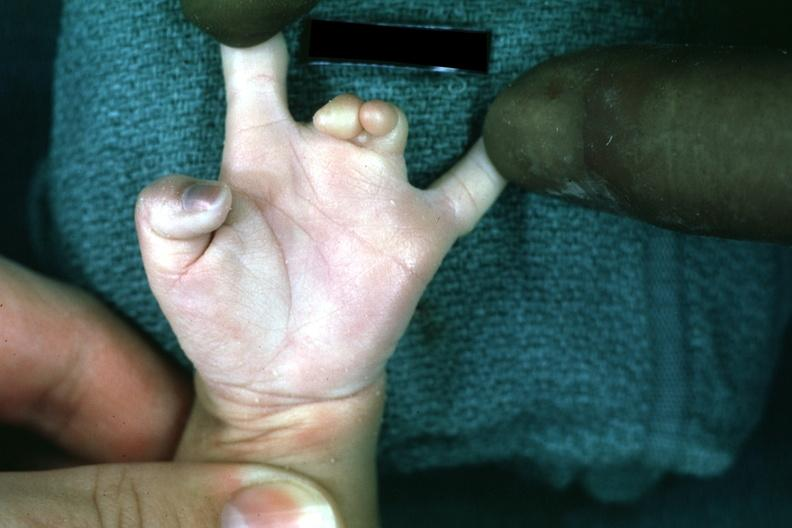does this image show syndactyly?
Answer the question using a single word or phrase. Yes 